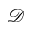<formula> <loc_0><loc_0><loc_500><loc_500>\mathcal { D }</formula> 